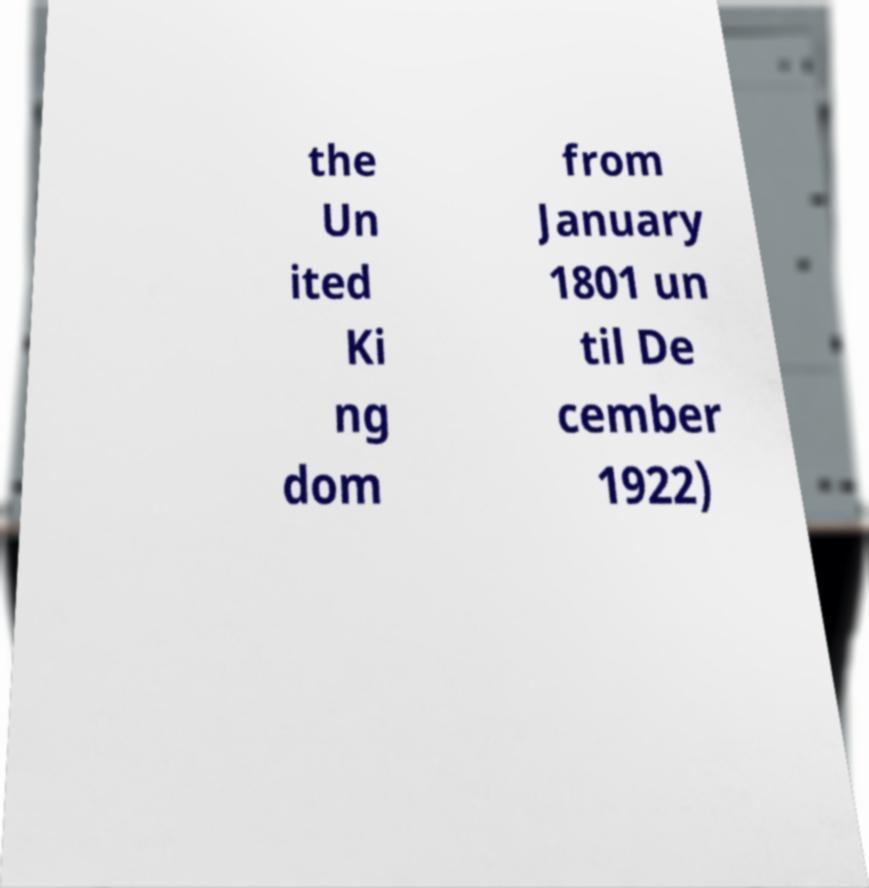Please read and relay the text visible in this image. What does it say? the Un ited Ki ng dom from January 1801 un til De cember 1922) 